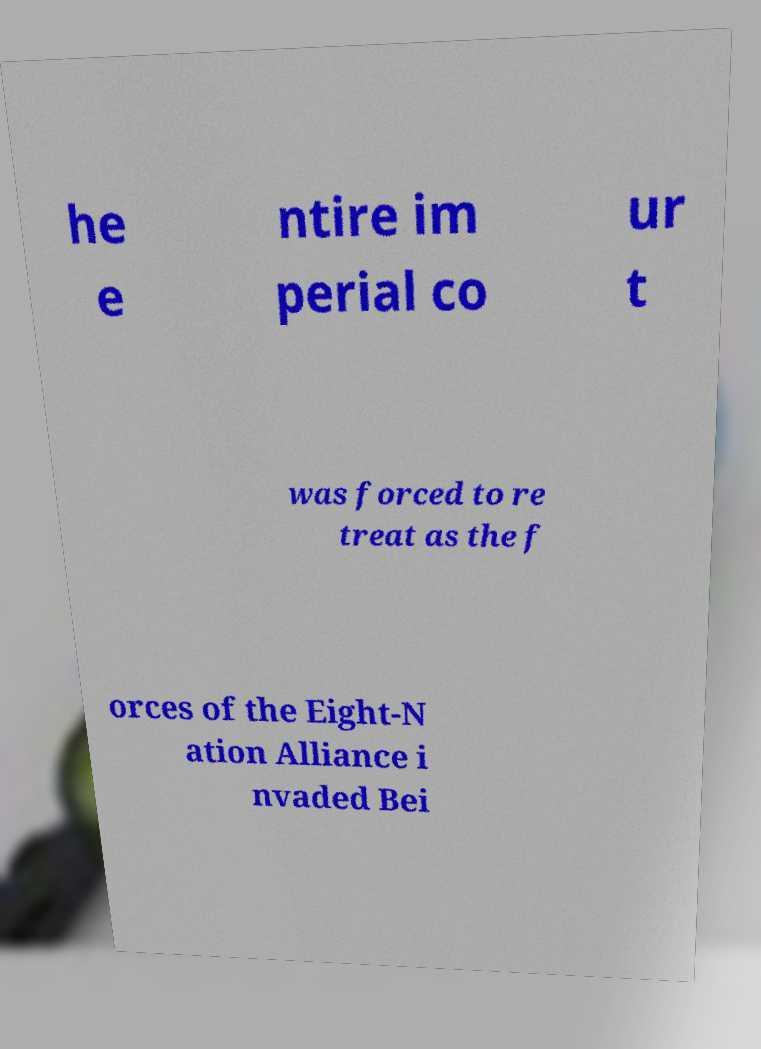What messages or text are displayed in this image? I need them in a readable, typed format. he e ntire im perial co ur t was forced to re treat as the f orces of the Eight-N ation Alliance i nvaded Bei 